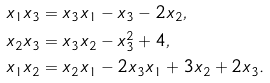<formula> <loc_0><loc_0><loc_500><loc_500>x _ { 1 } x _ { 3 } & = x _ { 3 } x _ { 1 } - x _ { 3 } - 2 x _ { 2 } , \\ x _ { 2 } x _ { 3 } & = x _ { 3 } x _ { 2 } - x _ { 3 } ^ { 2 } + 4 , \\ x _ { 1 } x _ { 2 } & = x _ { 2 } x _ { 1 } - 2 x _ { 3 } x _ { 1 } + 3 x _ { 2 } + 2 x _ { 3 } .</formula> 